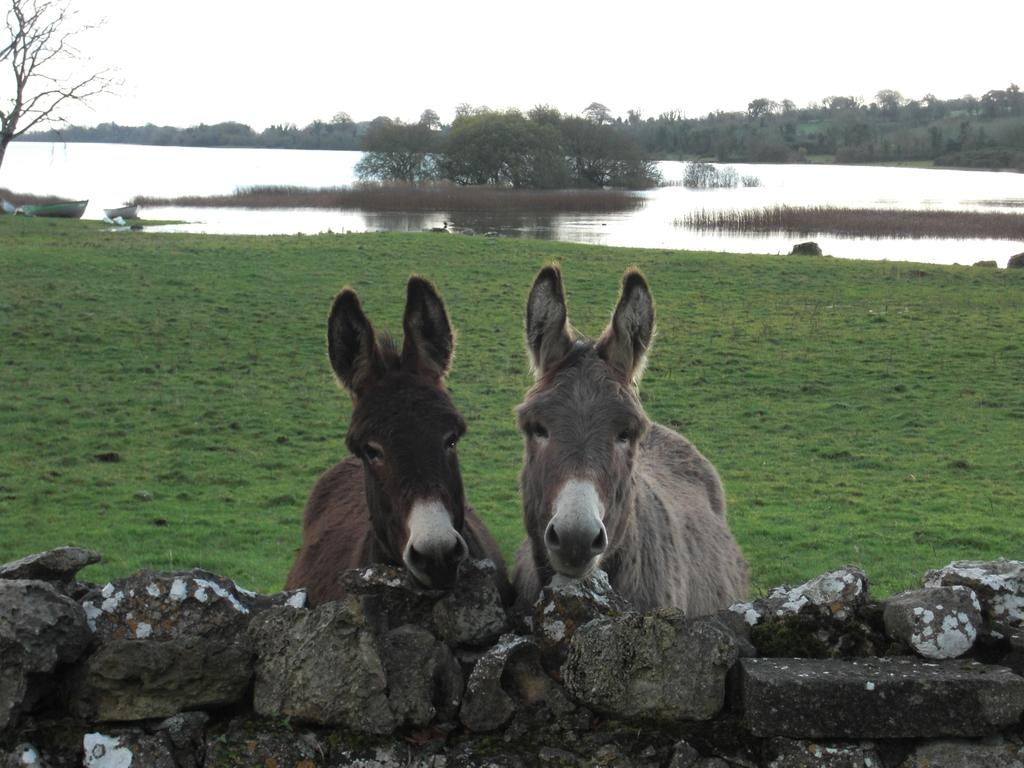How many animals can be seen in the image? There are two animals in the image. What is the background of the image? There is a wall, rocks, trees, and a lake in the image. What part of the natural environment is visible in the image? The sky is visible in the image. What type of cast is being used by the manager in the image? There is no cast or manager present in the image. What activity are the animals participating in during recess in the image? There is no recess or activity involving the animals in the image. 